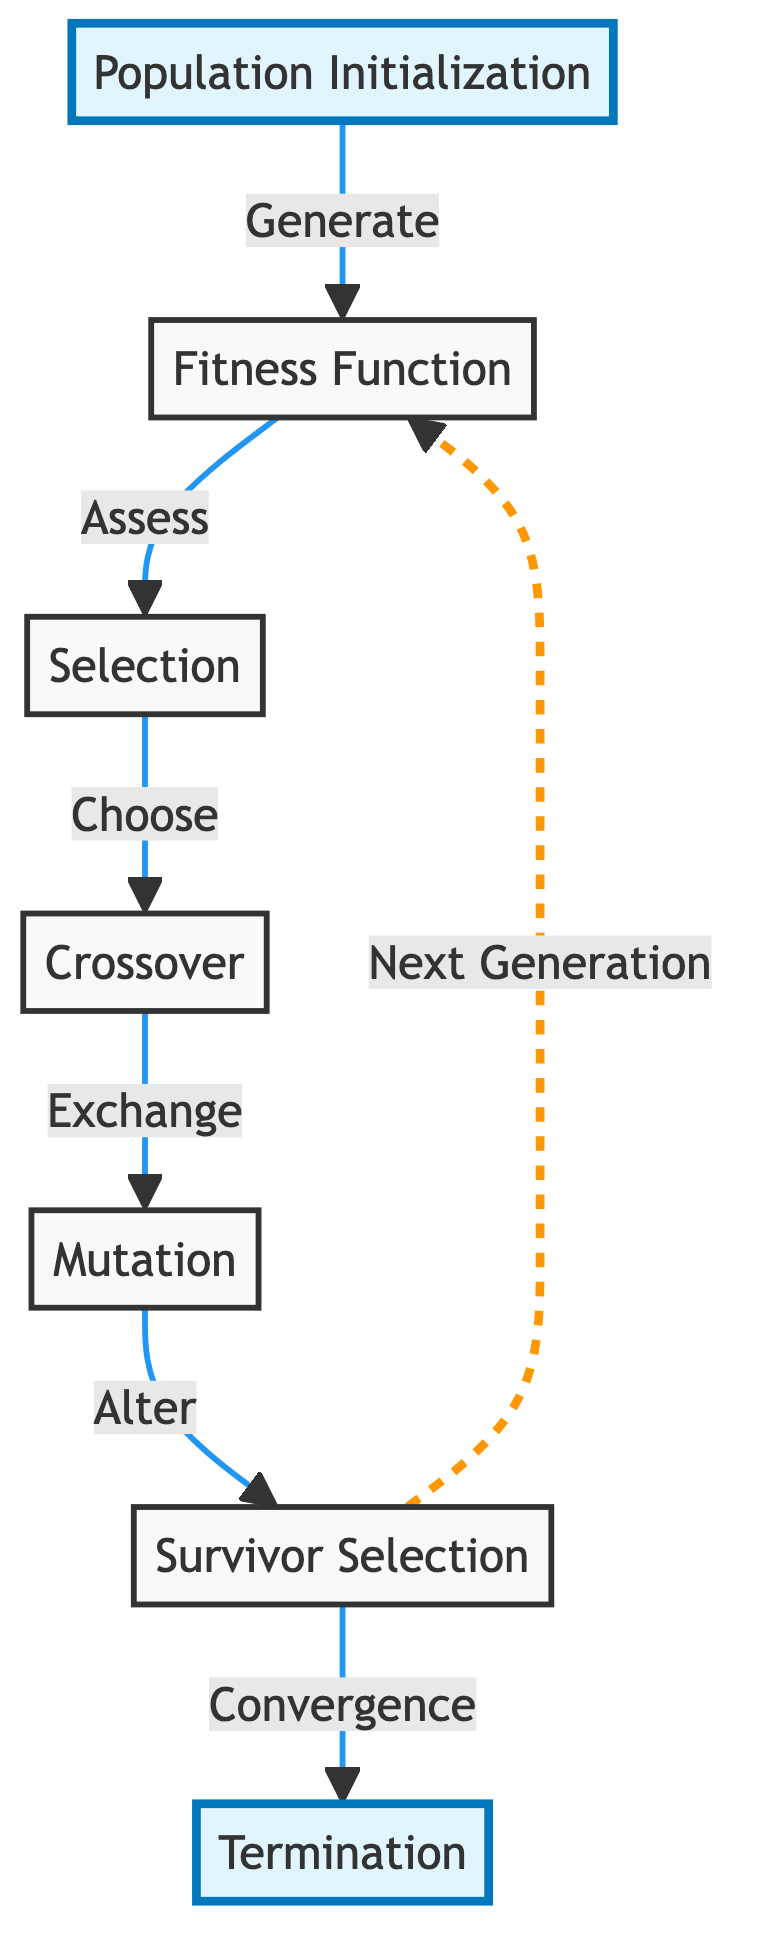What is the first step in the genetic algorithm process? The diagram begins with the node labeled "Population Initialization" which indicates that the first step is to initialize the population of individuals.
Answer: Population Initialization How many nodes are there in the diagram? By counting each labeled box in the diagram, there are a total of 7 nodes representing different processes in the genetic algorithm.
Answer: 7 What does the crossover process do in the genetic algorithm? The "Crossover" node indicates that this step is about exchanging genetic information between selected individuals to produce new offspring.
Answer: Exchange What is the last step before termination? The diagram shows that the last process leading to termination is "Survivor Selection," which decides which individuals continue to the next generation before reaching "Termination."
Answer: Survivor Selection Which node represents the assessment of the population? The "Fitness Function" node is where the individuals in the population are assessed based on their fitness before selection occurs.
Answer: Fitness Function How many connections lead from the survivor selection node? The "Survivor Selection" node has two connections leading out, one towards "Fitness Function" (indicating a loop) and another towards "Termination."
Answer: 2 What is the role of the mutation process? The "Mutation" node in the diagram illustrates that this step involves altering the genetic information of individuals to introduce variations into the population.
Answer: Alter What happens after the fitness function is assessed? After the fitness assessment, the diagram indicates that the next step is "Selection," where individuals are chosen based on their fitness for the crossover process.
Answer: Selection What color highlights the first and last steps in the genetic algorithm? In the diagram, both "Population Initialization" and "Termination" nodes are highlighted in a light blue shade, which distinguishes them from other nodes.
Answer: Light blue 